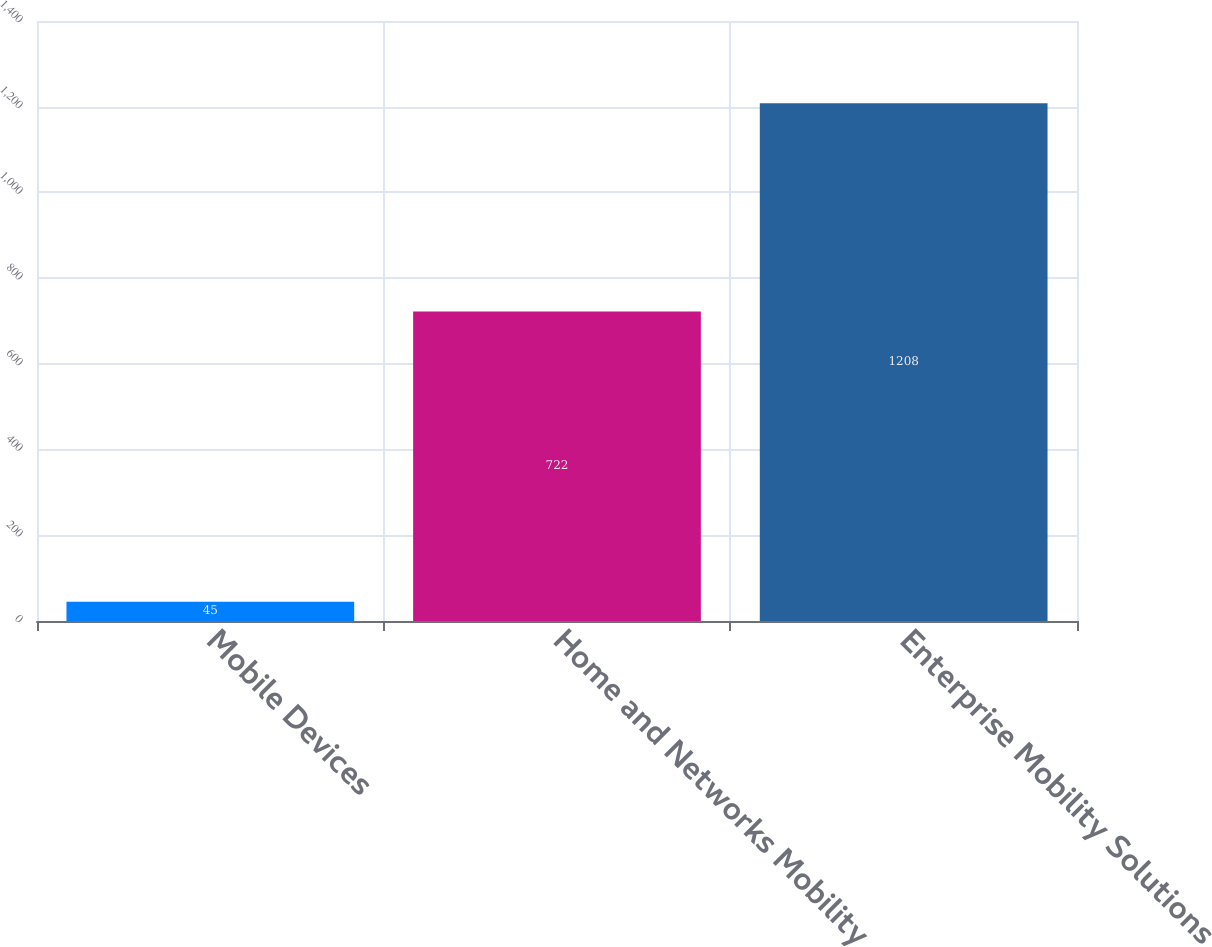Convert chart to OTSL. <chart><loc_0><loc_0><loc_500><loc_500><bar_chart><fcel>Mobile Devices<fcel>Home and Networks Mobility<fcel>Enterprise Mobility Solutions<nl><fcel>45<fcel>722<fcel>1208<nl></chart> 